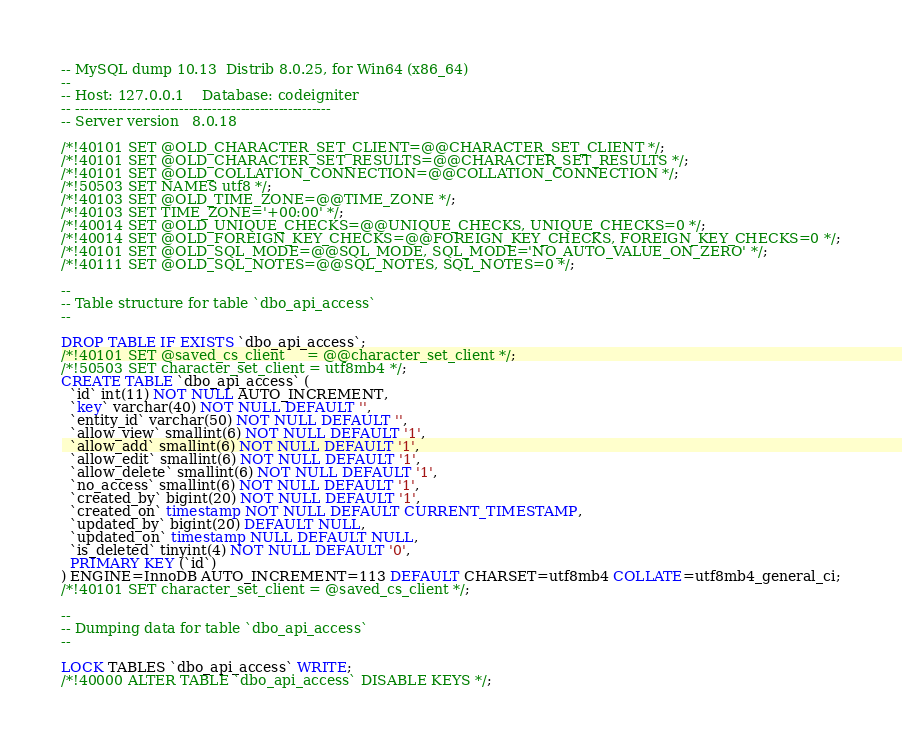<code> <loc_0><loc_0><loc_500><loc_500><_SQL_>-- MySQL dump 10.13  Distrib 8.0.25, for Win64 (x86_64)
--
-- Host: 127.0.0.1    Database: codeigniter
-- ------------------------------------------------------
-- Server version	8.0.18

/*!40101 SET @OLD_CHARACTER_SET_CLIENT=@@CHARACTER_SET_CLIENT */;
/*!40101 SET @OLD_CHARACTER_SET_RESULTS=@@CHARACTER_SET_RESULTS */;
/*!40101 SET @OLD_COLLATION_CONNECTION=@@COLLATION_CONNECTION */;
/*!50503 SET NAMES utf8 */;
/*!40103 SET @OLD_TIME_ZONE=@@TIME_ZONE */;
/*!40103 SET TIME_ZONE='+00:00' */;
/*!40014 SET @OLD_UNIQUE_CHECKS=@@UNIQUE_CHECKS, UNIQUE_CHECKS=0 */;
/*!40014 SET @OLD_FOREIGN_KEY_CHECKS=@@FOREIGN_KEY_CHECKS, FOREIGN_KEY_CHECKS=0 */;
/*!40101 SET @OLD_SQL_MODE=@@SQL_MODE, SQL_MODE='NO_AUTO_VALUE_ON_ZERO' */;
/*!40111 SET @OLD_SQL_NOTES=@@SQL_NOTES, SQL_NOTES=0 */;

--
-- Table structure for table `dbo_api_access`
--

DROP TABLE IF EXISTS `dbo_api_access`;
/*!40101 SET @saved_cs_client     = @@character_set_client */;
/*!50503 SET character_set_client = utf8mb4 */;
CREATE TABLE `dbo_api_access` (
  `id` int(11) NOT NULL AUTO_INCREMENT,
  `key` varchar(40) NOT NULL DEFAULT '',
  `entity_id` varchar(50) NOT NULL DEFAULT '',
  `allow_view` smallint(6) NOT NULL DEFAULT '1',
  `allow_add` smallint(6) NOT NULL DEFAULT '1',
  `allow_edit` smallint(6) NOT NULL DEFAULT '1',
  `allow_delete` smallint(6) NOT NULL DEFAULT '1',
  `no_access` smallint(6) NOT NULL DEFAULT '1',
  `created_by` bigint(20) NOT NULL DEFAULT '1',
  `created_on` timestamp NOT NULL DEFAULT CURRENT_TIMESTAMP,
  `updated_by` bigint(20) DEFAULT NULL,
  `updated_on` timestamp NULL DEFAULT NULL,
  `is_deleted` tinyint(4) NOT NULL DEFAULT '0',
  PRIMARY KEY (`id`)
) ENGINE=InnoDB AUTO_INCREMENT=113 DEFAULT CHARSET=utf8mb4 COLLATE=utf8mb4_general_ci;
/*!40101 SET character_set_client = @saved_cs_client */;

--
-- Dumping data for table `dbo_api_access`
--

LOCK TABLES `dbo_api_access` WRITE;
/*!40000 ALTER TABLE `dbo_api_access` DISABLE KEYS */;</code> 